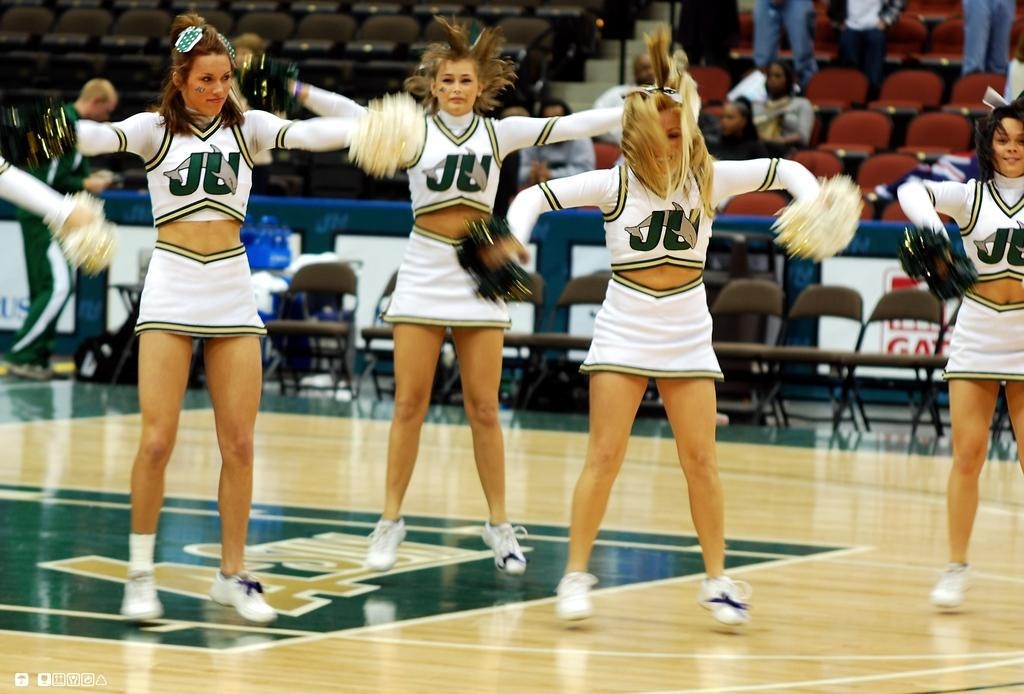<image>
Write a terse but informative summary of the picture. A group of cheerleaders are dancing on a basketball court and their uniforms say JU. 